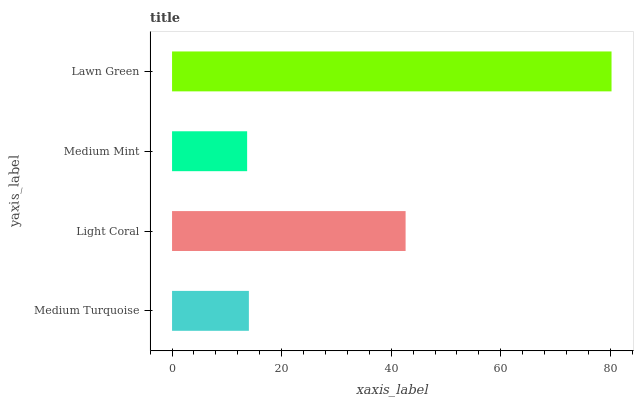Is Medium Mint the minimum?
Answer yes or no. Yes. Is Lawn Green the maximum?
Answer yes or no. Yes. Is Light Coral the minimum?
Answer yes or no. No. Is Light Coral the maximum?
Answer yes or no. No. Is Light Coral greater than Medium Turquoise?
Answer yes or no. Yes. Is Medium Turquoise less than Light Coral?
Answer yes or no. Yes. Is Medium Turquoise greater than Light Coral?
Answer yes or no. No. Is Light Coral less than Medium Turquoise?
Answer yes or no. No. Is Light Coral the high median?
Answer yes or no. Yes. Is Medium Turquoise the low median?
Answer yes or no. Yes. Is Lawn Green the high median?
Answer yes or no. No. Is Medium Mint the low median?
Answer yes or no. No. 